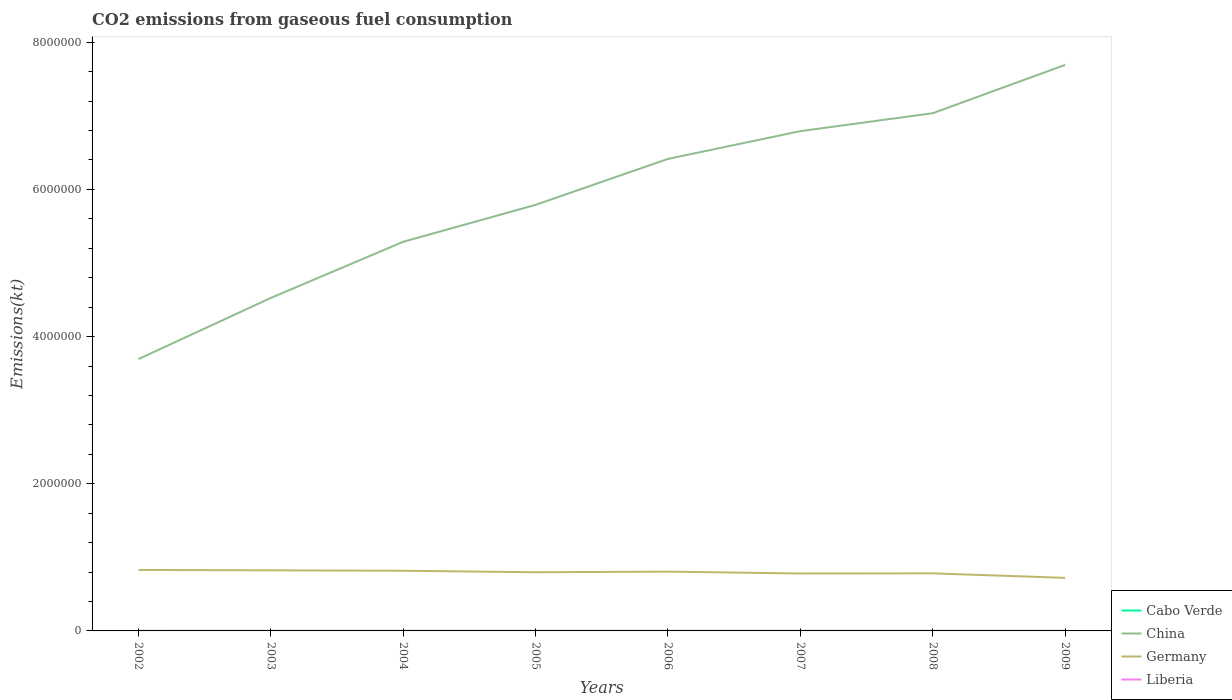How many different coloured lines are there?
Make the answer very short. 4. Does the line corresponding to China intersect with the line corresponding to Germany?
Give a very brief answer. No. Is the number of lines equal to the number of legend labels?
Provide a succinct answer. Yes. Across all years, what is the maximum amount of CO2 emitted in Cabo Verde?
Keep it short and to the point. 245.69. What is the total amount of CO2 emitted in Liberia in the graph?
Your response must be concise. 102.68. What is the difference between the highest and the second highest amount of CO2 emitted in Germany?
Ensure brevity in your answer.  1.08e+05. Is the amount of CO2 emitted in Germany strictly greater than the amount of CO2 emitted in Liberia over the years?
Provide a short and direct response. No. How many years are there in the graph?
Provide a succinct answer. 8. What is the difference between two consecutive major ticks on the Y-axis?
Your answer should be very brief. 2.00e+06. Are the values on the major ticks of Y-axis written in scientific E-notation?
Provide a short and direct response. No. How are the legend labels stacked?
Offer a terse response. Vertical. What is the title of the graph?
Give a very brief answer. CO2 emissions from gaseous fuel consumption. What is the label or title of the X-axis?
Your response must be concise. Years. What is the label or title of the Y-axis?
Provide a short and direct response. Emissions(kt). What is the Emissions(kt) in Cabo Verde in 2002?
Give a very brief answer. 245.69. What is the Emissions(kt) in China in 2002?
Your answer should be compact. 3.69e+06. What is the Emissions(kt) of Germany in 2002?
Your answer should be compact. 8.29e+05. What is the Emissions(kt) of Liberia in 2002?
Your response must be concise. 502.38. What is the Emissions(kt) of Cabo Verde in 2003?
Offer a very short reply. 253.02. What is the Emissions(kt) in China in 2003?
Ensure brevity in your answer.  4.53e+06. What is the Emissions(kt) in Germany in 2003?
Give a very brief answer. 8.23e+05. What is the Emissions(kt) of Liberia in 2003?
Keep it short and to the point. 531.72. What is the Emissions(kt) of Cabo Verde in 2004?
Provide a short and direct response. 264.02. What is the Emissions(kt) in China in 2004?
Provide a short and direct response. 5.29e+06. What is the Emissions(kt) in Germany in 2004?
Offer a very short reply. 8.18e+05. What is the Emissions(kt) in Liberia in 2004?
Make the answer very short. 627.06. What is the Emissions(kt) of Cabo Verde in 2005?
Your response must be concise. 293.36. What is the Emissions(kt) in China in 2005?
Offer a very short reply. 5.79e+06. What is the Emissions(kt) in Germany in 2005?
Your answer should be very brief. 7.97e+05. What is the Emissions(kt) of Liberia in 2005?
Your answer should be compact. 740.73. What is the Emissions(kt) of Cabo Verde in 2006?
Make the answer very short. 308.03. What is the Emissions(kt) in China in 2006?
Offer a very short reply. 6.41e+06. What is the Emissions(kt) in Germany in 2006?
Your answer should be compact. 8.06e+05. What is the Emissions(kt) in Liberia in 2006?
Your answer should be compact. 759.07. What is the Emissions(kt) in Cabo Verde in 2007?
Your answer should be compact. 370.37. What is the Emissions(kt) of China in 2007?
Provide a succinct answer. 6.79e+06. What is the Emissions(kt) in Germany in 2007?
Provide a succinct answer. 7.81e+05. What is the Emissions(kt) in Liberia in 2007?
Give a very brief answer. 678.39. What is the Emissions(kt) in Cabo Verde in 2008?
Ensure brevity in your answer.  286.03. What is the Emissions(kt) in China in 2008?
Provide a short and direct response. 7.04e+06. What is the Emissions(kt) of Germany in 2008?
Offer a very short reply. 7.82e+05. What is the Emissions(kt) in Liberia in 2008?
Your answer should be compact. 575.72. What is the Emissions(kt) in Cabo Verde in 2009?
Offer a terse response. 304.36. What is the Emissions(kt) of China in 2009?
Your response must be concise. 7.69e+06. What is the Emissions(kt) of Germany in 2009?
Provide a succinct answer. 7.21e+05. What is the Emissions(kt) of Liberia in 2009?
Offer a terse response. 528.05. Across all years, what is the maximum Emissions(kt) of Cabo Verde?
Give a very brief answer. 370.37. Across all years, what is the maximum Emissions(kt) in China?
Keep it short and to the point. 7.69e+06. Across all years, what is the maximum Emissions(kt) of Germany?
Offer a very short reply. 8.29e+05. Across all years, what is the maximum Emissions(kt) of Liberia?
Offer a very short reply. 759.07. Across all years, what is the minimum Emissions(kt) of Cabo Verde?
Ensure brevity in your answer.  245.69. Across all years, what is the minimum Emissions(kt) in China?
Provide a short and direct response. 3.69e+06. Across all years, what is the minimum Emissions(kt) in Germany?
Your answer should be very brief. 7.21e+05. Across all years, what is the minimum Emissions(kt) in Liberia?
Offer a very short reply. 502.38. What is the total Emissions(kt) in Cabo Verde in the graph?
Your answer should be compact. 2324.88. What is the total Emissions(kt) in China in the graph?
Your response must be concise. 4.72e+07. What is the total Emissions(kt) in Germany in the graph?
Provide a succinct answer. 6.36e+06. What is the total Emissions(kt) of Liberia in the graph?
Your answer should be very brief. 4943.12. What is the difference between the Emissions(kt) of Cabo Verde in 2002 and that in 2003?
Keep it short and to the point. -7.33. What is the difference between the Emissions(kt) of China in 2002 and that in 2003?
Your response must be concise. -8.31e+05. What is the difference between the Emissions(kt) in Germany in 2002 and that in 2003?
Keep it short and to the point. 5379.49. What is the difference between the Emissions(kt) of Liberia in 2002 and that in 2003?
Your answer should be compact. -29.34. What is the difference between the Emissions(kt) in Cabo Verde in 2002 and that in 2004?
Make the answer very short. -18.34. What is the difference between the Emissions(kt) in China in 2002 and that in 2004?
Your response must be concise. -1.59e+06. What is the difference between the Emissions(kt) of Germany in 2002 and that in 2004?
Provide a short and direct response. 1.11e+04. What is the difference between the Emissions(kt) of Liberia in 2002 and that in 2004?
Ensure brevity in your answer.  -124.68. What is the difference between the Emissions(kt) of Cabo Verde in 2002 and that in 2005?
Offer a very short reply. -47.67. What is the difference between the Emissions(kt) in China in 2002 and that in 2005?
Provide a short and direct response. -2.10e+06. What is the difference between the Emissions(kt) in Germany in 2002 and that in 2005?
Make the answer very short. 3.15e+04. What is the difference between the Emissions(kt) in Liberia in 2002 and that in 2005?
Offer a very short reply. -238.35. What is the difference between the Emissions(kt) of Cabo Verde in 2002 and that in 2006?
Provide a short and direct response. -62.34. What is the difference between the Emissions(kt) in China in 2002 and that in 2006?
Keep it short and to the point. -2.72e+06. What is the difference between the Emissions(kt) of Germany in 2002 and that in 2006?
Offer a terse response. 2.29e+04. What is the difference between the Emissions(kt) in Liberia in 2002 and that in 2006?
Your answer should be compact. -256.69. What is the difference between the Emissions(kt) in Cabo Verde in 2002 and that in 2007?
Your response must be concise. -124.68. What is the difference between the Emissions(kt) of China in 2002 and that in 2007?
Keep it short and to the point. -3.10e+06. What is the difference between the Emissions(kt) in Germany in 2002 and that in 2007?
Your answer should be compact. 4.81e+04. What is the difference between the Emissions(kt) in Liberia in 2002 and that in 2007?
Give a very brief answer. -176.02. What is the difference between the Emissions(kt) in Cabo Verde in 2002 and that in 2008?
Your answer should be very brief. -40.34. What is the difference between the Emissions(kt) of China in 2002 and that in 2008?
Your answer should be compact. -3.34e+06. What is the difference between the Emissions(kt) of Germany in 2002 and that in 2008?
Ensure brevity in your answer.  4.66e+04. What is the difference between the Emissions(kt) in Liberia in 2002 and that in 2008?
Make the answer very short. -73.34. What is the difference between the Emissions(kt) of Cabo Verde in 2002 and that in 2009?
Your response must be concise. -58.67. What is the difference between the Emissions(kt) of China in 2002 and that in 2009?
Offer a very short reply. -4.00e+06. What is the difference between the Emissions(kt) of Germany in 2002 and that in 2009?
Make the answer very short. 1.08e+05. What is the difference between the Emissions(kt) in Liberia in 2002 and that in 2009?
Your answer should be compact. -25.67. What is the difference between the Emissions(kt) in Cabo Verde in 2003 and that in 2004?
Offer a very short reply. -11. What is the difference between the Emissions(kt) in China in 2003 and that in 2004?
Offer a terse response. -7.63e+05. What is the difference between the Emissions(kt) of Germany in 2003 and that in 2004?
Give a very brief answer. 5680.18. What is the difference between the Emissions(kt) in Liberia in 2003 and that in 2004?
Provide a short and direct response. -95.34. What is the difference between the Emissions(kt) of Cabo Verde in 2003 and that in 2005?
Provide a succinct answer. -40.34. What is the difference between the Emissions(kt) in China in 2003 and that in 2005?
Your response must be concise. -1.26e+06. What is the difference between the Emissions(kt) of Germany in 2003 and that in 2005?
Keep it short and to the point. 2.61e+04. What is the difference between the Emissions(kt) of Liberia in 2003 and that in 2005?
Provide a short and direct response. -209.02. What is the difference between the Emissions(kt) in Cabo Verde in 2003 and that in 2006?
Ensure brevity in your answer.  -55.01. What is the difference between the Emissions(kt) of China in 2003 and that in 2006?
Provide a short and direct response. -1.89e+06. What is the difference between the Emissions(kt) of Germany in 2003 and that in 2006?
Offer a very short reply. 1.75e+04. What is the difference between the Emissions(kt) of Liberia in 2003 and that in 2006?
Keep it short and to the point. -227.35. What is the difference between the Emissions(kt) in Cabo Verde in 2003 and that in 2007?
Keep it short and to the point. -117.34. What is the difference between the Emissions(kt) in China in 2003 and that in 2007?
Provide a short and direct response. -2.27e+06. What is the difference between the Emissions(kt) in Germany in 2003 and that in 2007?
Provide a succinct answer. 4.28e+04. What is the difference between the Emissions(kt) of Liberia in 2003 and that in 2007?
Ensure brevity in your answer.  -146.68. What is the difference between the Emissions(kt) of Cabo Verde in 2003 and that in 2008?
Offer a very short reply. -33. What is the difference between the Emissions(kt) of China in 2003 and that in 2008?
Your answer should be compact. -2.51e+06. What is the difference between the Emissions(kt) in Germany in 2003 and that in 2008?
Provide a short and direct response. 4.12e+04. What is the difference between the Emissions(kt) in Liberia in 2003 and that in 2008?
Your answer should be compact. -44. What is the difference between the Emissions(kt) in Cabo Verde in 2003 and that in 2009?
Your response must be concise. -51.34. What is the difference between the Emissions(kt) of China in 2003 and that in 2009?
Your response must be concise. -3.17e+06. What is the difference between the Emissions(kt) in Germany in 2003 and that in 2009?
Offer a terse response. 1.02e+05. What is the difference between the Emissions(kt) of Liberia in 2003 and that in 2009?
Provide a short and direct response. 3.67. What is the difference between the Emissions(kt) in Cabo Verde in 2004 and that in 2005?
Ensure brevity in your answer.  -29.34. What is the difference between the Emissions(kt) of China in 2004 and that in 2005?
Provide a short and direct response. -5.02e+05. What is the difference between the Emissions(kt) of Germany in 2004 and that in 2005?
Your answer should be very brief. 2.04e+04. What is the difference between the Emissions(kt) in Liberia in 2004 and that in 2005?
Provide a short and direct response. -113.68. What is the difference between the Emissions(kt) in Cabo Verde in 2004 and that in 2006?
Your answer should be very brief. -44. What is the difference between the Emissions(kt) in China in 2004 and that in 2006?
Ensure brevity in your answer.  -1.13e+06. What is the difference between the Emissions(kt) in Germany in 2004 and that in 2006?
Your answer should be very brief. 1.19e+04. What is the difference between the Emissions(kt) in Liberia in 2004 and that in 2006?
Give a very brief answer. -132.01. What is the difference between the Emissions(kt) in Cabo Verde in 2004 and that in 2007?
Offer a terse response. -106.34. What is the difference between the Emissions(kt) in China in 2004 and that in 2007?
Ensure brevity in your answer.  -1.50e+06. What is the difference between the Emissions(kt) in Germany in 2004 and that in 2007?
Keep it short and to the point. 3.71e+04. What is the difference between the Emissions(kt) of Liberia in 2004 and that in 2007?
Offer a terse response. -51.34. What is the difference between the Emissions(kt) in Cabo Verde in 2004 and that in 2008?
Give a very brief answer. -22. What is the difference between the Emissions(kt) in China in 2004 and that in 2008?
Provide a succinct answer. -1.75e+06. What is the difference between the Emissions(kt) of Germany in 2004 and that in 2008?
Make the answer very short. 3.56e+04. What is the difference between the Emissions(kt) in Liberia in 2004 and that in 2008?
Your response must be concise. 51.34. What is the difference between the Emissions(kt) in Cabo Verde in 2004 and that in 2009?
Give a very brief answer. -40.34. What is the difference between the Emissions(kt) in China in 2004 and that in 2009?
Provide a short and direct response. -2.40e+06. What is the difference between the Emissions(kt) of Germany in 2004 and that in 2009?
Your response must be concise. 9.66e+04. What is the difference between the Emissions(kt) in Liberia in 2004 and that in 2009?
Your response must be concise. 99.01. What is the difference between the Emissions(kt) in Cabo Verde in 2005 and that in 2006?
Ensure brevity in your answer.  -14.67. What is the difference between the Emissions(kt) in China in 2005 and that in 2006?
Keep it short and to the point. -6.24e+05. What is the difference between the Emissions(kt) in Germany in 2005 and that in 2006?
Ensure brevity in your answer.  -8566.11. What is the difference between the Emissions(kt) of Liberia in 2005 and that in 2006?
Give a very brief answer. -18.34. What is the difference between the Emissions(kt) in Cabo Verde in 2005 and that in 2007?
Provide a short and direct response. -77.01. What is the difference between the Emissions(kt) in China in 2005 and that in 2007?
Make the answer very short. -1.00e+06. What is the difference between the Emissions(kt) of Germany in 2005 and that in 2007?
Provide a short and direct response. 1.67e+04. What is the difference between the Emissions(kt) in Liberia in 2005 and that in 2007?
Offer a very short reply. 62.34. What is the difference between the Emissions(kt) in Cabo Verde in 2005 and that in 2008?
Your answer should be very brief. 7.33. What is the difference between the Emissions(kt) of China in 2005 and that in 2008?
Provide a succinct answer. -1.25e+06. What is the difference between the Emissions(kt) in Germany in 2005 and that in 2008?
Provide a succinct answer. 1.51e+04. What is the difference between the Emissions(kt) of Liberia in 2005 and that in 2008?
Ensure brevity in your answer.  165.01. What is the difference between the Emissions(kt) in Cabo Verde in 2005 and that in 2009?
Your answer should be compact. -11. What is the difference between the Emissions(kt) of China in 2005 and that in 2009?
Your response must be concise. -1.90e+06. What is the difference between the Emissions(kt) of Germany in 2005 and that in 2009?
Your response must be concise. 7.62e+04. What is the difference between the Emissions(kt) in Liberia in 2005 and that in 2009?
Your response must be concise. 212.69. What is the difference between the Emissions(kt) of Cabo Verde in 2006 and that in 2007?
Make the answer very short. -62.34. What is the difference between the Emissions(kt) in China in 2006 and that in 2007?
Offer a very short reply. -3.77e+05. What is the difference between the Emissions(kt) in Germany in 2006 and that in 2007?
Your answer should be compact. 2.52e+04. What is the difference between the Emissions(kt) in Liberia in 2006 and that in 2007?
Make the answer very short. 80.67. What is the difference between the Emissions(kt) in Cabo Verde in 2006 and that in 2008?
Offer a terse response. 22. What is the difference between the Emissions(kt) of China in 2006 and that in 2008?
Ensure brevity in your answer.  -6.21e+05. What is the difference between the Emissions(kt) of Germany in 2006 and that in 2008?
Your answer should be very brief. 2.37e+04. What is the difference between the Emissions(kt) of Liberia in 2006 and that in 2008?
Keep it short and to the point. 183.35. What is the difference between the Emissions(kt) of Cabo Verde in 2006 and that in 2009?
Give a very brief answer. 3.67. What is the difference between the Emissions(kt) in China in 2006 and that in 2009?
Your answer should be very brief. -1.28e+06. What is the difference between the Emissions(kt) of Germany in 2006 and that in 2009?
Your answer should be very brief. 8.48e+04. What is the difference between the Emissions(kt) in Liberia in 2006 and that in 2009?
Make the answer very short. 231.02. What is the difference between the Emissions(kt) of Cabo Verde in 2007 and that in 2008?
Provide a succinct answer. 84.34. What is the difference between the Emissions(kt) in China in 2007 and that in 2008?
Ensure brevity in your answer.  -2.44e+05. What is the difference between the Emissions(kt) in Germany in 2007 and that in 2008?
Provide a short and direct response. -1525.47. What is the difference between the Emissions(kt) in Liberia in 2007 and that in 2008?
Provide a short and direct response. 102.68. What is the difference between the Emissions(kt) of Cabo Verde in 2007 and that in 2009?
Provide a short and direct response. 66.01. What is the difference between the Emissions(kt) in China in 2007 and that in 2009?
Offer a very short reply. -9.00e+05. What is the difference between the Emissions(kt) in Germany in 2007 and that in 2009?
Ensure brevity in your answer.  5.96e+04. What is the difference between the Emissions(kt) of Liberia in 2007 and that in 2009?
Provide a short and direct response. 150.35. What is the difference between the Emissions(kt) in Cabo Verde in 2008 and that in 2009?
Provide a succinct answer. -18.34. What is the difference between the Emissions(kt) in China in 2008 and that in 2009?
Your answer should be very brief. -6.57e+05. What is the difference between the Emissions(kt) in Germany in 2008 and that in 2009?
Ensure brevity in your answer.  6.11e+04. What is the difference between the Emissions(kt) in Liberia in 2008 and that in 2009?
Offer a very short reply. 47.67. What is the difference between the Emissions(kt) in Cabo Verde in 2002 and the Emissions(kt) in China in 2003?
Your answer should be very brief. -4.52e+06. What is the difference between the Emissions(kt) of Cabo Verde in 2002 and the Emissions(kt) of Germany in 2003?
Offer a very short reply. -8.23e+05. What is the difference between the Emissions(kt) of Cabo Verde in 2002 and the Emissions(kt) of Liberia in 2003?
Make the answer very short. -286.03. What is the difference between the Emissions(kt) in China in 2002 and the Emissions(kt) in Germany in 2003?
Your answer should be very brief. 2.87e+06. What is the difference between the Emissions(kt) in China in 2002 and the Emissions(kt) in Liberia in 2003?
Your answer should be compact. 3.69e+06. What is the difference between the Emissions(kt) in Germany in 2002 and the Emissions(kt) in Liberia in 2003?
Offer a very short reply. 8.28e+05. What is the difference between the Emissions(kt) of Cabo Verde in 2002 and the Emissions(kt) of China in 2004?
Your answer should be very brief. -5.29e+06. What is the difference between the Emissions(kt) in Cabo Verde in 2002 and the Emissions(kt) in Germany in 2004?
Offer a very short reply. -8.17e+05. What is the difference between the Emissions(kt) of Cabo Verde in 2002 and the Emissions(kt) of Liberia in 2004?
Offer a terse response. -381.37. What is the difference between the Emissions(kt) in China in 2002 and the Emissions(kt) in Germany in 2004?
Your answer should be very brief. 2.88e+06. What is the difference between the Emissions(kt) of China in 2002 and the Emissions(kt) of Liberia in 2004?
Offer a terse response. 3.69e+06. What is the difference between the Emissions(kt) of Germany in 2002 and the Emissions(kt) of Liberia in 2004?
Ensure brevity in your answer.  8.28e+05. What is the difference between the Emissions(kt) in Cabo Verde in 2002 and the Emissions(kt) in China in 2005?
Offer a very short reply. -5.79e+06. What is the difference between the Emissions(kt) in Cabo Verde in 2002 and the Emissions(kt) in Germany in 2005?
Your response must be concise. -7.97e+05. What is the difference between the Emissions(kt) of Cabo Verde in 2002 and the Emissions(kt) of Liberia in 2005?
Your answer should be very brief. -495.05. What is the difference between the Emissions(kt) in China in 2002 and the Emissions(kt) in Germany in 2005?
Give a very brief answer. 2.90e+06. What is the difference between the Emissions(kt) of China in 2002 and the Emissions(kt) of Liberia in 2005?
Provide a short and direct response. 3.69e+06. What is the difference between the Emissions(kt) in Germany in 2002 and the Emissions(kt) in Liberia in 2005?
Your response must be concise. 8.28e+05. What is the difference between the Emissions(kt) in Cabo Verde in 2002 and the Emissions(kt) in China in 2006?
Offer a very short reply. -6.41e+06. What is the difference between the Emissions(kt) in Cabo Verde in 2002 and the Emissions(kt) in Germany in 2006?
Offer a very short reply. -8.06e+05. What is the difference between the Emissions(kt) in Cabo Verde in 2002 and the Emissions(kt) in Liberia in 2006?
Make the answer very short. -513.38. What is the difference between the Emissions(kt) in China in 2002 and the Emissions(kt) in Germany in 2006?
Offer a terse response. 2.89e+06. What is the difference between the Emissions(kt) in China in 2002 and the Emissions(kt) in Liberia in 2006?
Give a very brief answer. 3.69e+06. What is the difference between the Emissions(kt) of Germany in 2002 and the Emissions(kt) of Liberia in 2006?
Offer a very short reply. 8.28e+05. What is the difference between the Emissions(kt) of Cabo Verde in 2002 and the Emissions(kt) of China in 2007?
Make the answer very short. -6.79e+06. What is the difference between the Emissions(kt) of Cabo Verde in 2002 and the Emissions(kt) of Germany in 2007?
Your response must be concise. -7.80e+05. What is the difference between the Emissions(kt) in Cabo Verde in 2002 and the Emissions(kt) in Liberia in 2007?
Provide a short and direct response. -432.71. What is the difference between the Emissions(kt) of China in 2002 and the Emissions(kt) of Germany in 2007?
Keep it short and to the point. 2.91e+06. What is the difference between the Emissions(kt) of China in 2002 and the Emissions(kt) of Liberia in 2007?
Keep it short and to the point. 3.69e+06. What is the difference between the Emissions(kt) of Germany in 2002 and the Emissions(kt) of Liberia in 2007?
Ensure brevity in your answer.  8.28e+05. What is the difference between the Emissions(kt) in Cabo Verde in 2002 and the Emissions(kt) in China in 2008?
Give a very brief answer. -7.04e+06. What is the difference between the Emissions(kt) in Cabo Verde in 2002 and the Emissions(kt) in Germany in 2008?
Provide a succinct answer. -7.82e+05. What is the difference between the Emissions(kt) in Cabo Verde in 2002 and the Emissions(kt) in Liberia in 2008?
Ensure brevity in your answer.  -330.03. What is the difference between the Emissions(kt) in China in 2002 and the Emissions(kt) in Germany in 2008?
Your answer should be compact. 2.91e+06. What is the difference between the Emissions(kt) in China in 2002 and the Emissions(kt) in Liberia in 2008?
Provide a succinct answer. 3.69e+06. What is the difference between the Emissions(kt) of Germany in 2002 and the Emissions(kt) of Liberia in 2008?
Give a very brief answer. 8.28e+05. What is the difference between the Emissions(kt) of Cabo Verde in 2002 and the Emissions(kt) of China in 2009?
Your answer should be very brief. -7.69e+06. What is the difference between the Emissions(kt) of Cabo Verde in 2002 and the Emissions(kt) of Germany in 2009?
Your answer should be very brief. -7.21e+05. What is the difference between the Emissions(kt) of Cabo Verde in 2002 and the Emissions(kt) of Liberia in 2009?
Provide a succinct answer. -282.36. What is the difference between the Emissions(kt) of China in 2002 and the Emissions(kt) of Germany in 2009?
Offer a very short reply. 2.97e+06. What is the difference between the Emissions(kt) in China in 2002 and the Emissions(kt) in Liberia in 2009?
Your answer should be compact. 3.69e+06. What is the difference between the Emissions(kt) in Germany in 2002 and the Emissions(kt) in Liberia in 2009?
Ensure brevity in your answer.  8.28e+05. What is the difference between the Emissions(kt) of Cabo Verde in 2003 and the Emissions(kt) of China in 2004?
Your response must be concise. -5.29e+06. What is the difference between the Emissions(kt) of Cabo Verde in 2003 and the Emissions(kt) of Germany in 2004?
Ensure brevity in your answer.  -8.17e+05. What is the difference between the Emissions(kt) of Cabo Verde in 2003 and the Emissions(kt) of Liberia in 2004?
Keep it short and to the point. -374.03. What is the difference between the Emissions(kt) in China in 2003 and the Emissions(kt) in Germany in 2004?
Provide a succinct answer. 3.71e+06. What is the difference between the Emissions(kt) of China in 2003 and the Emissions(kt) of Liberia in 2004?
Keep it short and to the point. 4.52e+06. What is the difference between the Emissions(kt) in Germany in 2003 and the Emissions(kt) in Liberia in 2004?
Offer a terse response. 8.23e+05. What is the difference between the Emissions(kt) in Cabo Verde in 2003 and the Emissions(kt) in China in 2005?
Offer a terse response. -5.79e+06. What is the difference between the Emissions(kt) of Cabo Verde in 2003 and the Emissions(kt) of Germany in 2005?
Make the answer very short. -7.97e+05. What is the difference between the Emissions(kt) of Cabo Verde in 2003 and the Emissions(kt) of Liberia in 2005?
Ensure brevity in your answer.  -487.71. What is the difference between the Emissions(kt) in China in 2003 and the Emissions(kt) in Germany in 2005?
Your answer should be very brief. 3.73e+06. What is the difference between the Emissions(kt) in China in 2003 and the Emissions(kt) in Liberia in 2005?
Provide a short and direct response. 4.52e+06. What is the difference between the Emissions(kt) in Germany in 2003 and the Emissions(kt) in Liberia in 2005?
Your answer should be very brief. 8.23e+05. What is the difference between the Emissions(kt) of Cabo Verde in 2003 and the Emissions(kt) of China in 2006?
Offer a terse response. -6.41e+06. What is the difference between the Emissions(kt) of Cabo Verde in 2003 and the Emissions(kt) of Germany in 2006?
Your answer should be very brief. -8.06e+05. What is the difference between the Emissions(kt) of Cabo Verde in 2003 and the Emissions(kt) of Liberia in 2006?
Give a very brief answer. -506.05. What is the difference between the Emissions(kt) of China in 2003 and the Emissions(kt) of Germany in 2006?
Your response must be concise. 3.72e+06. What is the difference between the Emissions(kt) in China in 2003 and the Emissions(kt) in Liberia in 2006?
Ensure brevity in your answer.  4.52e+06. What is the difference between the Emissions(kt) in Germany in 2003 and the Emissions(kt) in Liberia in 2006?
Provide a succinct answer. 8.23e+05. What is the difference between the Emissions(kt) of Cabo Verde in 2003 and the Emissions(kt) of China in 2007?
Your response must be concise. -6.79e+06. What is the difference between the Emissions(kt) in Cabo Verde in 2003 and the Emissions(kt) in Germany in 2007?
Your answer should be very brief. -7.80e+05. What is the difference between the Emissions(kt) in Cabo Verde in 2003 and the Emissions(kt) in Liberia in 2007?
Your response must be concise. -425.37. What is the difference between the Emissions(kt) of China in 2003 and the Emissions(kt) of Germany in 2007?
Provide a succinct answer. 3.74e+06. What is the difference between the Emissions(kt) in China in 2003 and the Emissions(kt) in Liberia in 2007?
Offer a very short reply. 4.52e+06. What is the difference between the Emissions(kt) of Germany in 2003 and the Emissions(kt) of Liberia in 2007?
Offer a very short reply. 8.23e+05. What is the difference between the Emissions(kt) in Cabo Verde in 2003 and the Emissions(kt) in China in 2008?
Keep it short and to the point. -7.04e+06. What is the difference between the Emissions(kt) in Cabo Verde in 2003 and the Emissions(kt) in Germany in 2008?
Ensure brevity in your answer.  -7.82e+05. What is the difference between the Emissions(kt) of Cabo Verde in 2003 and the Emissions(kt) of Liberia in 2008?
Keep it short and to the point. -322.7. What is the difference between the Emissions(kt) in China in 2003 and the Emissions(kt) in Germany in 2008?
Your answer should be very brief. 3.74e+06. What is the difference between the Emissions(kt) of China in 2003 and the Emissions(kt) of Liberia in 2008?
Give a very brief answer. 4.52e+06. What is the difference between the Emissions(kt) of Germany in 2003 and the Emissions(kt) of Liberia in 2008?
Provide a short and direct response. 8.23e+05. What is the difference between the Emissions(kt) in Cabo Verde in 2003 and the Emissions(kt) in China in 2009?
Your response must be concise. -7.69e+06. What is the difference between the Emissions(kt) of Cabo Verde in 2003 and the Emissions(kt) of Germany in 2009?
Ensure brevity in your answer.  -7.21e+05. What is the difference between the Emissions(kt) in Cabo Verde in 2003 and the Emissions(kt) in Liberia in 2009?
Keep it short and to the point. -275.02. What is the difference between the Emissions(kt) in China in 2003 and the Emissions(kt) in Germany in 2009?
Your answer should be compact. 3.80e+06. What is the difference between the Emissions(kt) of China in 2003 and the Emissions(kt) of Liberia in 2009?
Give a very brief answer. 4.52e+06. What is the difference between the Emissions(kt) of Germany in 2003 and the Emissions(kt) of Liberia in 2009?
Make the answer very short. 8.23e+05. What is the difference between the Emissions(kt) in Cabo Verde in 2004 and the Emissions(kt) in China in 2005?
Your response must be concise. -5.79e+06. What is the difference between the Emissions(kt) of Cabo Verde in 2004 and the Emissions(kt) of Germany in 2005?
Provide a short and direct response. -7.97e+05. What is the difference between the Emissions(kt) of Cabo Verde in 2004 and the Emissions(kt) of Liberia in 2005?
Your answer should be very brief. -476.71. What is the difference between the Emissions(kt) in China in 2004 and the Emissions(kt) in Germany in 2005?
Offer a very short reply. 4.49e+06. What is the difference between the Emissions(kt) of China in 2004 and the Emissions(kt) of Liberia in 2005?
Your answer should be compact. 5.29e+06. What is the difference between the Emissions(kt) of Germany in 2004 and the Emissions(kt) of Liberia in 2005?
Keep it short and to the point. 8.17e+05. What is the difference between the Emissions(kt) of Cabo Verde in 2004 and the Emissions(kt) of China in 2006?
Provide a succinct answer. -6.41e+06. What is the difference between the Emissions(kt) of Cabo Verde in 2004 and the Emissions(kt) of Germany in 2006?
Give a very brief answer. -8.06e+05. What is the difference between the Emissions(kt) of Cabo Verde in 2004 and the Emissions(kt) of Liberia in 2006?
Ensure brevity in your answer.  -495.05. What is the difference between the Emissions(kt) of China in 2004 and the Emissions(kt) of Germany in 2006?
Ensure brevity in your answer.  4.48e+06. What is the difference between the Emissions(kt) in China in 2004 and the Emissions(kt) in Liberia in 2006?
Keep it short and to the point. 5.29e+06. What is the difference between the Emissions(kt) of Germany in 2004 and the Emissions(kt) of Liberia in 2006?
Make the answer very short. 8.17e+05. What is the difference between the Emissions(kt) in Cabo Verde in 2004 and the Emissions(kt) in China in 2007?
Provide a short and direct response. -6.79e+06. What is the difference between the Emissions(kt) of Cabo Verde in 2004 and the Emissions(kt) of Germany in 2007?
Your answer should be compact. -7.80e+05. What is the difference between the Emissions(kt) of Cabo Verde in 2004 and the Emissions(kt) of Liberia in 2007?
Offer a very short reply. -414.37. What is the difference between the Emissions(kt) in China in 2004 and the Emissions(kt) in Germany in 2007?
Give a very brief answer. 4.51e+06. What is the difference between the Emissions(kt) in China in 2004 and the Emissions(kt) in Liberia in 2007?
Make the answer very short. 5.29e+06. What is the difference between the Emissions(kt) of Germany in 2004 and the Emissions(kt) of Liberia in 2007?
Make the answer very short. 8.17e+05. What is the difference between the Emissions(kt) in Cabo Verde in 2004 and the Emissions(kt) in China in 2008?
Give a very brief answer. -7.04e+06. What is the difference between the Emissions(kt) in Cabo Verde in 2004 and the Emissions(kt) in Germany in 2008?
Your response must be concise. -7.82e+05. What is the difference between the Emissions(kt) in Cabo Verde in 2004 and the Emissions(kt) in Liberia in 2008?
Your answer should be very brief. -311.69. What is the difference between the Emissions(kt) of China in 2004 and the Emissions(kt) of Germany in 2008?
Make the answer very short. 4.51e+06. What is the difference between the Emissions(kt) in China in 2004 and the Emissions(kt) in Liberia in 2008?
Ensure brevity in your answer.  5.29e+06. What is the difference between the Emissions(kt) of Germany in 2004 and the Emissions(kt) of Liberia in 2008?
Give a very brief answer. 8.17e+05. What is the difference between the Emissions(kt) in Cabo Verde in 2004 and the Emissions(kt) in China in 2009?
Provide a short and direct response. -7.69e+06. What is the difference between the Emissions(kt) of Cabo Verde in 2004 and the Emissions(kt) of Germany in 2009?
Ensure brevity in your answer.  -7.21e+05. What is the difference between the Emissions(kt) of Cabo Verde in 2004 and the Emissions(kt) of Liberia in 2009?
Provide a succinct answer. -264.02. What is the difference between the Emissions(kt) in China in 2004 and the Emissions(kt) in Germany in 2009?
Make the answer very short. 4.57e+06. What is the difference between the Emissions(kt) in China in 2004 and the Emissions(kt) in Liberia in 2009?
Provide a short and direct response. 5.29e+06. What is the difference between the Emissions(kt) of Germany in 2004 and the Emissions(kt) of Liberia in 2009?
Your answer should be very brief. 8.17e+05. What is the difference between the Emissions(kt) in Cabo Verde in 2005 and the Emissions(kt) in China in 2006?
Ensure brevity in your answer.  -6.41e+06. What is the difference between the Emissions(kt) of Cabo Verde in 2005 and the Emissions(kt) of Germany in 2006?
Offer a very short reply. -8.06e+05. What is the difference between the Emissions(kt) in Cabo Verde in 2005 and the Emissions(kt) in Liberia in 2006?
Ensure brevity in your answer.  -465.71. What is the difference between the Emissions(kt) of China in 2005 and the Emissions(kt) of Germany in 2006?
Provide a succinct answer. 4.98e+06. What is the difference between the Emissions(kt) of China in 2005 and the Emissions(kt) of Liberia in 2006?
Keep it short and to the point. 5.79e+06. What is the difference between the Emissions(kt) in Germany in 2005 and the Emissions(kt) in Liberia in 2006?
Your answer should be very brief. 7.97e+05. What is the difference between the Emissions(kt) in Cabo Verde in 2005 and the Emissions(kt) in China in 2007?
Keep it short and to the point. -6.79e+06. What is the difference between the Emissions(kt) of Cabo Verde in 2005 and the Emissions(kt) of Germany in 2007?
Your response must be concise. -7.80e+05. What is the difference between the Emissions(kt) in Cabo Verde in 2005 and the Emissions(kt) in Liberia in 2007?
Offer a terse response. -385.04. What is the difference between the Emissions(kt) of China in 2005 and the Emissions(kt) of Germany in 2007?
Give a very brief answer. 5.01e+06. What is the difference between the Emissions(kt) of China in 2005 and the Emissions(kt) of Liberia in 2007?
Your answer should be very brief. 5.79e+06. What is the difference between the Emissions(kt) of Germany in 2005 and the Emissions(kt) of Liberia in 2007?
Offer a very short reply. 7.97e+05. What is the difference between the Emissions(kt) in Cabo Verde in 2005 and the Emissions(kt) in China in 2008?
Offer a very short reply. -7.04e+06. What is the difference between the Emissions(kt) in Cabo Verde in 2005 and the Emissions(kt) in Germany in 2008?
Make the answer very short. -7.82e+05. What is the difference between the Emissions(kt) in Cabo Verde in 2005 and the Emissions(kt) in Liberia in 2008?
Your answer should be compact. -282.36. What is the difference between the Emissions(kt) in China in 2005 and the Emissions(kt) in Germany in 2008?
Your response must be concise. 5.01e+06. What is the difference between the Emissions(kt) of China in 2005 and the Emissions(kt) of Liberia in 2008?
Give a very brief answer. 5.79e+06. What is the difference between the Emissions(kt) in Germany in 2005 and the Emissions(kt) in Liberia in 2008?
Your answer should be very brief. 7.97e+05. What is the difference between the Emissions(kt) in Cabo Verde in 2005 and the Emissions(kt) in China in 2009?
Offer a terse response. -7.69e+06. What is the difference between the Emissions(kt) in Cabo Verde in 2005 and the Emissions(kt) in Germany in 2009?
Keep it short and to the point. -7.21e+05. What is the difference between the Emissions(kt) in Cabo Verde in 2005 and the Emissions(kt) in Liberia in 2009?
Provide a short and direct response. -234.69. What is the difference between the Emissions(kt) in China in 2005 and the Emissions(kt) in Germany in 2009?
Your answer should be very brief. 5.07e+06. What is the difference between the Emissions(kt) in China in 2005 and the Emissions(kt) in Liberia in 2009?
Your answer should be very brief. 5.79e+06. What is the difference between the Emissions(kt) of Germany in 2005 and the Emissions(kt) of Liberia in 2009?
Keep it short and to the point. 7.97e+05. What is the difference between the Emissions(kt) of Cabo Verde in 2006 and the Emissions(kt) of China in 2007?
Ensure brevity in your answer.  -6.79e+06. What is the difference between the Emissions(kt) in Cabo Verde in 2006 and the Emissions(kt) in Germany in 2007?
Your response must be concise. -7.80e+05. What is the difference between the Emissions(kt) in Cabo Verde in 2006 and the Emissions(kt) in Liberia in 2007?
Your answer should be compact. -370.37. What is the difference between the Emissions(kt) of China in 2006 and the Emissions(kt) of Germany in 2007?
Provide a short and direct response. 5.63e+06. What is the difference between the Emissions(kt) of China in 2006 and the Emissions(kt) of Liberia in 2007?
Offer a terse response. 6.41e+06. What is the difference between the Emissions(kt) of Germany in 2006 and the Emissions(kt) of Liberia in 2007?
Keep it short and to the point. 8.05e+05. What is the difference between the Emissions(kt) of Cabo Verde in 2006 and the Emissions(kt) of China in 2008?
Ensure brevity in your answer.  -7.04e+06. What is the difference between the Emissions(kt) in Cabo Verde in 2006 and the Emissions(kt) in Germany in 2008?
Make the answer very short. -7.82e+05. What is the difference between the Emissions(kt) in Cabo Verde in 2006 and the Emissions(kt) in Liberia in 2008?
Offer a very short reply. -267.69. What is the difference between the Emissions(kt) in China in 2006 and the Emissions(kt) in Germany in 2008?
Your response must be concise. 5.63e+06. What is the difference between the Emissions(kt) in China in 2006 and the Emissions(kt) in Liberia in 2008?
Offer a very short reply. 6.41e+06. What is the difference between the Emissions(kt) of Germany in 2006 and the Emissions(kt) of Liberia in 2008?
Your response must be concise. 8.05e+05. What is the difference between the Emissions(kt) in Cabo Verde in 2006 and the Emissions(kt) in China in 2009?
Your response must be concise. -7.69e+06. What is the difference between the Emissions(kt) of Cabo Verde in 2006 and the Emissions(kt) of Germany in 2009?
Your answer should be very brief. -7.21e+05. What is the difference between the Emissions(kt) in Cabo Verde in 2006 and the Emissions(kt) in Liberia in 2009?
Your answer should be compact. -220.02. What is the difference between the Emissions(kt) in China in 2006 and the Emissions(kt) in Germany in 2009?
Offer a terse response. 5.69e+06. What is the difference between the Emissions(kt) in China in 2006 and the Emissions(kt) in Liberia in 2009?
Make the answer very short. 6.41e+06. What is the difference between the Emissions(kt) in Germany in 2006 and the Emissions(kt) in Liberia in 2009?
Provide a short and direct response. 8.05e+05. What is the difference between the Emissions(kt) of Cabo Verde in 2007 and the Emissions(kt) of China in 2008?
Your answer should be very brief. -7.04e+06. What is the difference between the Emissions(kt) of Cabo Verde in 2007 and the Emissions(kt) of Germany in 2008?
Your answer should be compact. -7.82e+05. What is the difference between the Emissions(kt) of Cabo Verde in 2007 and the Emissions(kt) of Liberia in 2008?
Your response must be concise. -205.35. What is the difference between the Emissions(kt) of China in 2007 and the Emissions(kt) of Germany in 2008?
Offer a very short reply. 6.01e+06. What is the difference between the Emissions(kt) in China in 2007 and the Emissions(kt) in Liberia in 2008?
Your response must be concise. 6.79e+06. What is the difference between the Emissions(kt) of Germany in 2007 and the Emissions(kt) of Liberia in 2008?
Give a very brief answer. 7.80e+05. What is the difference between the Emissions(kt) of Cabo Verde in 2007 and the Emissions(kt) of China in 2009?
Your answer should be very brief. -7.69e+06. What is the difference between the Emissions(kt) of Cabo Verde in 2007 and the Emissions(kt) of Germany in 2009?
Make the answer very short. -7.21e+05. What is the difference between the Emissions(kt) of Cabo Verde in 2007 and the Emissions(kt) of Liberia in 2009?
Your answer should be compact. -157.68. What is the difference between the Emissions(kt) in China in 2007 and the Emissions(kt) in Germany in 2009?
Your answer should be compact. 6.07e+06. What is the difference between the Emissions(kt) in China in 2007 and the Emissions(kt) in Liberia in 2009?
Provide a short and direct response. 6.79e+06. What is the difference between the Emissions(kt) of Germany in 2007 and the Emissions(kt) of Liberia in 2009?
Offer a very short reply. 7.80e+05. What is the difference between the Emissions(kt) in Cabo Verde in 2008 and the Emissions(kt) in China in 2009?
Your response must be concise. -7.69e+06. What is the difference between the Emissions(kt) in Cabo Verde in 2008 and the Emissions(kt) in Germany in 2009?
Provide a short and direct response. -7.21e+05. What is the difference between the Emissions(kt) of Cabo Verde in 2008 and the Emissions(kt) of Liberia in 2009?
Your response must be concise. -242.02. What is the difference between the Emissions(kt) in China in 2008 and the Emissions(kt) in Germany in 2009?
Give a very brief answer. 6.31e+06. What is the difference between the Emissions(kt) of China in 2008 and the Emissions(kt) of Liberia in 2009?
Make the answer very short. 7.03e+06. What is the difference between the Emissions(kt) of Germany in 2008 and the Emissions(kt) of Liberia in 2009?
Offer a very short reply. 7.82e+05. What is the average Emissions(kt) of Cabo Verde per year?
Provide a succinct answer. 290.61. What is the average Emissions(kt) of China per year?
Your answer should be very brief. 5.90e+06. What is the average Emissions(kt) of Germany per year?
Make the answer very short. 7.95e+05. What is the average Emissions(kt) of Liberia per year?
Your answer should be compact. 617.89. In the year 2002, what is the difference between the Emissions(kt) in Cabo Verde and Emissions(kt) in China?
Offer a very short reply. -3.69e+06. In the year 2002, what is the difference between the Emissions(kt) of Cabo Verde and Emissions(kt) of Germany?
Provide a succinct answer. -8.29e+05. In the year 2002, what is the difference between the Emissions(kt) in Cabo Verde and Emissions(kt) in Liberia?
Offer a terse response. -256.69. In the year 2002, what is the difference between the Emissions(kt) of China and Emissions(kt) of Germany?
Your answer should be very brief. 2.87e+06. In the year 2002, what is the difference between the Emissions(kt) in China and Emissions(kt) in Liberia?
Make the answer very short. 3.69e+06. In the year 2002, what is the difference between the Emissions(kt) in Germany and Emissions(kt) in Liberia?
Offer a very short reply. 8.28e+05. In the year 2003, what is the difference between the Emissions(kt) of Cabo Verde and Emissions(kt) of China?
Your response must be concise. -4.52e+06. In the year 2003, what is the difference between the Emissions(kt) in Cabo Verde and Emissions(kt) in Germany?
Provide a short and direct response. -8.23e+05. In the year 2003, what is the difference between the Emissions(kt) of Cabo Verde and Emissions(kt) of Liberia?
Keep it short and to the point. -278.69. In the year 2003, what is the difference between the Emissions(kt) in China and Emissions(kt) in Germany?
Give a very brief answer. 3.70e+06. In the year 2003, what is the difference between the Emissions(kt) of China and Emissions(kt) of Liberia?
Provide a succinct answer. 4.52e+06. In the year 2003, what is the difference between the Emissions(kt) in Germany and Emissions(kt) in Liberia?
Your response must be concise. 8.23e+05. In the year 2004, what is the difference between the Emissions(kt) of Cabo Verde and Emissions(kt) of China?
Provide a short and direct response. -5.29e+06. In the year 2004, what is the difference between the Emissions(kt) in Cabo Verde and Emissions(kt) in Germany?
Provide a succinct answer. -8.17e+05. In the year 2004, what is the difference between the Emissions(kt) in Cabo Verde and Emissions(kt) in Liberia?
Provide a succinct answer. -363.03. In the year 2004, what is the difference between the Emissions(kt) of China and Emissions(kt) of Germany?
Ensure brevity in your answer.  4.47e+06. In the year 2004, what is the difference between the Emissions(kt) of China and Emissions(kt) of Liberia?
Your answer should be compact. 5.29e+06. In the year 2004, what is the difference between the Emissions(kt) in Germany and Emissions(kt) in Liberia?
Keep it short and to the point. 8.17e+05. In the year 2005, what is the difference between the Emissions(kt) of Cabo Verde and Emissions(kt) of China?
Provide a short and direct response. -5.79e+06. In the year 2005, what is the difference between the Emissions(kt) in Cabo Verde and Emissions(kt) in Germany?
Give a very brief answer. -7.97e+05. In the year 2005, what is the difference between the Emissions(kt) in Cabo Verde and Emissions(kt) in Liberia?
Offer a very short reply. -447.37. In the year 2005, what is the difference between the Emissions(kt) of China and Emissions(kt) of Germany?
Offer a terse response. 4.99e+06. In the year 2005, what is the difference between the Emissions(kt) in China and Emissions(kt) in Liberia?
Offer a terse response. 5.79e+06. In the year 2005, what is the difference between the Emissions(kt) in Germany and Emissions(kt) in Liberia?
Your response must be concise. 7.97e+05. In the year 2006, what is the difference between the Emissions(kt) in Cabo Verde and Emissions(kt) in China?
Your answer should be very brief. -6.41e+06. In the year 2006, what is the difference between the Emissions(kt) in Cabo Verde and Emissions(kt) in Germany?
Make the answer very short. -8.06e+05. In the year 2006, what is the difference between the Emissions(kt) in Cabo Verde and Emissions(kt) in Liberia?
Offer a very short reply. -451.04. In the year 2006, what is the difference between the Emissions(kt) of China and Emissions(kt) of Germany?
Make the answer very short. 5.61e+06. In the year 2006, what is the difference between the Emissions(kt) in China and Emissions(kt) in Liberia?
Provide a short and direct response. 6.41e+06. In the year 2006, what is the difference between the Emissions(kt) of Germany and Emissions(kt) of Liberia?
Make the answer very short. 8.05e+05. In the year 2007, what is the difference between the Emissions(kt) of Cabo Verde and Emissions(kt) of China?
Keep it short and to the point. -6.79e+06. In the year 2007, what is the difference between the Emissions(kt) in Cabo Verde and Emissions(kt) in Germany?
Provide a succinct answer. -7.80e+05. In the year 2007, what is the difference between the Emissions(kt) of Cabo Verde and Emissions(kt) of Liberia?
Provide a short and direct response. -308.03. In the year 2007, what is the difference between the Emissions(kt) in China and Emissions(kt) in Germany?
Your answer should be very brief. 6.01e+06. In the year 2007, what is the difference between the Emissions(kt) in China and Emissions(kt) in Liberia?
Keep it short and to the point. 6.79e+06. In the year 2007, what is the difference between the Emissions(kt) of Germany and Emissions(kt) of Liberia?
Your answer should be compact. 7.80e+05. In the year 2008, what is the difference between the Emissions(kt) of Cabo Verde and Emissions(kt) of China?
Give a very brief answer. -7.04e+06. In the year 2008, what is the difference between the Emissions(kt) in Cabo Verde and Emissions(kt) in Germany?
Make the answer very short. -7.82e+05. In the year 2008, what is the difference between the Emissions(kt) of Cabo Verde and Emissions(kt) of Liberia?
Provide a short and direct response. -289.69. In the year 2008, what is the difference between the Emissions(kt) in China and Emissions(kt) in Germany?
Ensure brevity in your answer.  6.25e+06. In the year 2008, what is the difference between the Emissions(kt) of China and Emissions(kt) of Liberia?
Your response must be concise. 7.03e+06. In the year 2008, what is the difference between the Emissions(kt) in Germany and Emissions(kt) in Liberia?
Offer a very short reply. 7.82e+05. In the year 2009, what is the difference between the Emissions(kt) in Cabo Verde and Emissions(kt) in China?
Your answer should be very brief. -7.69e+06. In the year 2009, what is the difference between the Emissions(kt) in Cabo Verde and Emissions(kt) in Germany?
Your answer should be very brief. -7.21e+05. In the year 2009, what is the difference between the Emissions(kt) of Cabo Verde and Emissions(kt) of Liberia?
Your response must be concise. -223.69. In the year 2009, what is the difference between the Emissions(kt) of China and Emissions(kt) of Germany?
Provide a short and direct response. 6.97e+06. In the year 2009, what is the difference between the Emissions(kt) of China and Emissions(kt) of Liberia?
Your response must be concise. 7.69e+06. In the year 2009, what is the difference between the Emissions(kt) of Germany and Emissions(kt) of Liberia?
Provide a succinct answer. 7.21e+05. What is the ratio of the Emissions(kt) of Cabo Verde in 2002 to that in 2003?
Your answer should be compact. 0.97. What is the ratio of the Emissions(kt) in China in 2002 to that in 2003?
Keep it short and to the point. 0.82. What is the ratio of the Emissions(kt) of Germany in 2002 to that in 2003?
Your response must be concise. 1.01. What is the ratio of the Emissions(kt) in Liberia in 2002 to that in 2003?
Your answer should be very brief. 0.94. What is the ratio of the Emissions(kt) in Cabo Verde in 2002 to that in 2004?
Make the answer very short. 0.93. What is the ratio of the Emissions(kt) of China in 2002 to that in 2004?
Your response must be concise. 0.7. What is the ratio of the Emissions(kt) of Germany in 2002 to that in 2004?
Offer a very short reply. 1.01. What is the ratio of the Emissions(kt) in Liberia in 2002 to that in 2004?
Provide a short and direct response. 0.8. What is the ratio of the Emissions(kt) of Cabo Verde in 2002 to that in 2005?
Your answer should be very brief. 0.84. What is the ratio of the Emissions(kt) in China in 2002 to that in 2005?
Provide a short and direct response. 0.64. What is the ratio of the Emissions(kt) of Germany in 2002 to that in 2005?
Your answer should be very brief. 1.04. What is the ratio of the Emissions(kt) of Liberia in 2002 to that in 2005?
Make the answer very short. 0.68. What is the ratio of the Emissions(kt) of Cabo Verde in 2002 to that in 2006?
Your answer should be very brief. 0.8. What is the ratio of the Emissions(kt) of China in 2002 to that in 2006?
Your answer should be compact. 0.58. What is the ratio of the Emissions(kt) in Germany in 2002 to that in 2006?
Make the answer very short. 1.03. What is the ratio of the Emissions(kt) of Liberia in 2002 to that in 2006?
Keep it short and to the point. 0.66. What is the ratio of the Emissions(kt) in Cabo Verde in 2002 to that in 2007?
Offer a terse response. 0.66. What is the ratio of the Emissions(kt) of China in 2002 to that in 2007?
Make the answer very short. 0.54. What is the ratio of the Emissions(kt) in Germany in 2002 to that in 2007?
Keep it short and to the point. 1.06. What is the ratio of the Emissions(kt) in Liberia in 2002 to that in 2007?
Keep it short and to the point. 0.74. What is the ratio of the Emissions(kt) of Cabo Verde in 2002 to that in 2008?
Offer a terse response. 0.86. What is the ratio of the Emissions(kt) of China in 2002 to that in 2008?
Make the answer very short. 0.53. What is the ratio of the Emissions(kt) in Germany in 2002 to that in 2008?
Your answer should be very brief. 1.06. What is the ratio of the Emissions(kt) in Liberia in 2002 to that in 2008?
Offer a very short reply. 0.87. What is the ratio of the Emissions(kt) of Cabo Verde in 2002 to that in 2009?
Provide a short and direct response. 0.81. What is the ratio of the Emissions(kt) of China in 2002 to that in 2009?
Give a very brief answer. 0.48. What is the ratio of the Emissions(kt) of Germany in 2002 to that in 2009?
Your answer should be compact. 1.15. What is the ratio of the Emissions(kt) in Liberia in 2002 to that in 2009?
Your answer should be compact. 0.95. What is the ratio of the Emissions(kt) in Cabo Verde in 2003 to that in 2004?
Provide a succinct answer. 0.96. What is the ratio of the Emissions(kt) of China in 2003 to that in 2004?
Give a very brief answer. 0.86. What is the ratio of the Emissions(kt) in Liberia in 2003 to that in 2004?
Your answer should be very brief. 0.85. What is the ratio of the Emissions(kt) in Cabo Verde in 2003 to that in 2005?
Make the answer very short. 0.86. What is the ratio of the Emissions(kt) in China in 2003 to that in 2005?
Offer a terse response. 0.78. What is the ratio of the Emissions(kt) of Germany in 2003 to that in 2005?
Your answer should be very brief. 1.03. What is the ratio of the Emissions(kt) of Liberia in 2003 to that in 2005?
Provide a succinct answer. 0.72. What is the ratio of the Emissions(kt) of Cabo Verde in 2003 to that in 2006?
Make the answer very short. 0.82. What is the ratio of the Emissions(kt) in China in 2003 to that in 2006?
Your answer should be compact. 0.71. What is the ratio of the Emissions(kt) in Germany in 2003 to that in 2006?
Offer a very short reply. 1.02. What is the ratio of the Emissions(kt) in Liberia in 2003 to that in 2006?
Offer a terse response. 0.7. What is the ratio of the Emissions(kt) of Cabo Verde in 2003 to that in 2007?
Your answer should be very brief. 0.68. What is the ratio of the Emissions(kt) of China in 2003 to that in 2007?
Make the answer very short. 0.67. What is the ratio of the Emissions(kt) in Germany in 2003 to that in 2007?
Provide a short and direct response. 1.05. What is the ratio of the Emissions(kt) in Liberia in 2003 to that in 2007?
Offer a very short reply. 0.78. What is the ratio of the Emissions(kt) of Cabo Verde in 2003 to that in 2008?
Your answer should be very brief. 0.88. What is the ratio of the Emissions(kt) of China in 2003 to that in 2008?
Your answer should be very brief. 0.64. What is the ratio of the Emissions(kt) of Germany in 2003 to that in 2008?
Offer a terse response. 1.05. What is the ratio of the Emissions(kt) of Liberia in 2003 to that in 2008?
Offer a very short reply. 0.92. What is the ratio of the Emissions(kt) of Cabo Verde in 2003 to that in 2009?
Give a very brief answer. 0.83. What is the ratio of the Emissions(kt) in China in 2003 to that in 2009?
Your answer should be very brief. 0.59. What is the ratio of the Emissions(kt) of Germany in 2003 to that in 2009?
Offer a terse response. 1.14. What is the ratio of the Emissions(kt) of Liberia in 2003 to that in 2009?
Provide a succinct answer. 1.01. What is the ratio of the Emissions(kt) in Cabo Verde in 2004 to that in 2005?
Offer a very short reply. 0.9. What is the ratio of the Emissions(kt) in China in 2004 to that in 2005?
Offer a terse response. 0.91. What is the ratio of the Emissions(kt) of Germany in 2004 to that in 2005?
Your answer should be compact. 1.03. What is the ratio of the Emissions(kt) in Liberia in 2004 to that in 2005?
Offer a very short reply. 0.85. What is the ratio of the Emissions(kt) in Cabo Verde in 2004 to that in 2006?
Your response must be concise. 0.86. What is the ratio of the Emissions(kt) of China in 2004 to that in 2006?
Your answer should be compact. 0.82. What is the ratio of the Emissions(kt) in Germany in 2004 to that in 2006?
Offer a terse response. 1.01. What is the ratio of the Emissions(kt) in Liberia in 2004 to that in 2006?
Make the answer very short. 0.83. What is the ratio of the Emissions(kt) of Cabo Verde in 2004 to that in 2007?
Make the answer very short. 0.71. What is the ratio of the Emissions(kt) in China in 2004 to that in 2007?
Make the answer very short. 0.78. What is the ratio of the Emissions(kt) of Germany in 2004 to that in 2007?
Offer a very short reply. 1.05. What is the ratio of the Emissions(kt) of Liberia in 2004 to that in 2007?
Ensure brevity in your answer.  0.92. What is the ratio of the Emissions(kt) of Cabo Verde in 2004 to that in 2008?
Give a very brief answer. 0.92. What is the ratio of the Emissions(kt) in China in 2004 to that in 2008?
Provide a succinct answer. 0.75. What is the ratio of the Emissions(kt) of Germany in 2004 to that in 2008?
Provide a succinct answer. 1.05. What is the ratio of the Emissions(kt) of Liberia in 2004 to that in 2008?
Your response must be concise. 1.09. What is the ratio of the Emissions(kt) in Cabo Verde in 2004 to that in 2009?
Keep it short and to the point. 0.87. What is the ratio of the Emissions(kt) of China in 2004 to that in 2009?
Keep it short and to the point. 0.69. What is the ratio of the Emissions(kt) in Germany in 2004 to that in 2009?
Your response must be concise. 1.13. What is the ratio of the Emissions(kt) in Liberia in 2004 to that in 2009?
Provide a succinct answer. 1.19. What is the ratio of the Emissions(kt) of China in 2005 to that in 2006?
Keep it short and to the point. 0.9. What is the ratio of the Emissions(kt) in Liberia in 2005 to that in 2006?
Your answer should be compact. 0.98. What is the ratio of the Emissions(kt) in Cabo Verde in 2005 to that in 2007?
Make the answer very short. 0.79. What is the ratio of the Emissions(kt) of China in 2005 to that in 2007?
Offer a very short reply. 0.85. What is the ratio of the Emissions(kt) of Germany in 2005 to that in 2007?
Provide a succinct answer. 1.02. What is the ratio of the Emissions(kt) in Liberia in 2005 to that in 2007?
Keep it short and to the point. 1.09. What is the ratio of the Emissions(kt) in Cabo Verde in 2005 to that in 2008?
Your answer should be very brief. 1.03. What is the ratio of the Emissions(kt) in China in 2005 to that in 2008?
Provide a succinct answer. 0.82. What is the ratio of the Emissions(kt) of Germany in 2005 to that in 2008?
Your answer should be compact. 1.02. What is the ratio of the Emissions(kt) in Liberia in 2005 to that in 2008?
Keep it short and to the point. 1.29. What is the ratio of the Emissions(kt) in Cabo Verde in 2005 to that in 2009?
Provide a short and direct response. 0.96. What is the ratio of the Emissions(kt) in China in 2005 to that in 2009?
Your answer should be compact. 0.75. What is the ratio of the Emissions(kt) in Germany in 2005 to that in 2009?
Make the answer very short. 1.11. What is the ratio of the Emissions(kt) of Liberia in 2005 to that in 2009?
Provide a short and direct response. 1.4. What is the ratio of the Emissions(kt) in Cabo Verde in 2006 to that in 2007?
Offer a very short reply. 0.83. What is the ratio of the Emissions(kt) in Germany in 2006 to that in 2007?
Offer a very short reply. 1.03. What is the ratio of the Emissions(kt) of Liberia in 2006 to that in 2007?
Your response must be concise. 1.12. What is the ratio of the Emissions(kt) of Cabo Verde in 2006 to that in 2008?
Offer a very short reply. 1.08. What is the ratio of the Emissions(kt) in China in 2006 to that in 2008?
Provide a succinct answer. 0.91. What is the ratio of the Emissions(kt) in Germany in 2006 to that in 2008?
Offer a terse response. 1.03. What is the ratio of the Emissions(kt) of Liberia in 2006 to that in 2008?
Keep it short and to the point. 1.32. What is the ratio of the Emissions(kt) in Cabo Verde in 2006 to that in 2009?
Give a very brief answer. 1.01. What is the ratio of the Emissions(kt) of China in 2006 to that in 2009?
Provide a succinct answer. 0.83. What is the ratio of the Emissions(kt) of Germany in 2006 to that in 2009?
Your response must be concise. 1.12. What is the ratio of the Emissions(kt) in Liberia in 2006 to that in 2009?
Your answer should be compact. 1.44. What is the ratio of the Emissions(kt) of Cabo Verde in 2007 to that in 2008?
Ensure brevity in your answer.  1.29. What is the ratio of the Emissions(kt) in China in 2007 to that in 2008?
Your answer should be compact. 0.97. What is the ratio of the Emissions(kt) of Germany in 2007 to that in 2008?
Your response must be concise. 1. What is the ratio of the Emissions(kt) of Liberia in 2007 to that in 2008?
Provide a succinct answer. 1.18. What is the ratio of the Emissions(kt) in Cabo Verde in 2007 to that in 2009?
Provide a succinct answer. 1.22. What is the ratio of the Emissions(kt) in China in 2007 to that in 2009?
Provide a succinct answer. 0.88. What is the ratio of the Emissions(kt) in Germany in 2007 to that in 2009?
Ensure brevity in your answer.  1.08. What is the ratio of the Emissions(kt) in Liberia in 2007 to that in 2009?
Offer a terse response. 1.28. What is the ratio of the Emissions(kt) in Cabo Verde in 2008 to that in 2009?
Offer a very short reply. 0.94. What is the ratio of the Emissions(kt) in China in 2008 to that in 2009?
Your response must be concise. 0.91. What is the ratio of the Emissions(kt) in Germany in 2008 to that in 2009?
Your answer should be compact. 1.08. What is the ratio of the Emissions(kt) in Liberia in 2008 to that in 2009?
Ensure brevity in your answer.  1.09. What is the difference between the highest and the second highest Emissions(kt) of Cabo Verde?
Your response must be concise. 62.34. What is the difference between the highest and the second highest Emissions(kt) in China?
Provide a succinct answer. 6.57e+05. What is the difference between the highest and the second highest Emissions(kt) of Germany?
Offer a very short reply. 5379.49. What is the difference between the highest and the second highest Emissions(kt) in Liberia?
Keep it short and to the point. 18.34. What is the difference between the highest and the lowest Emissions(kt) of Cabo Verde?
Make the answer very short. 124.68. What is the difference between the highest and the lowest Emissions(kt) of China?
Your response must be concise. 4.00e+06. What is the difference between the highest and the lowest Emissions(kt) in Germany?
Offer a very short reply. 1.08e+05. What is the difference between the highest and the lowest Emissions(kt) in Liberia?
Provide a short and direct response. 256.69. 